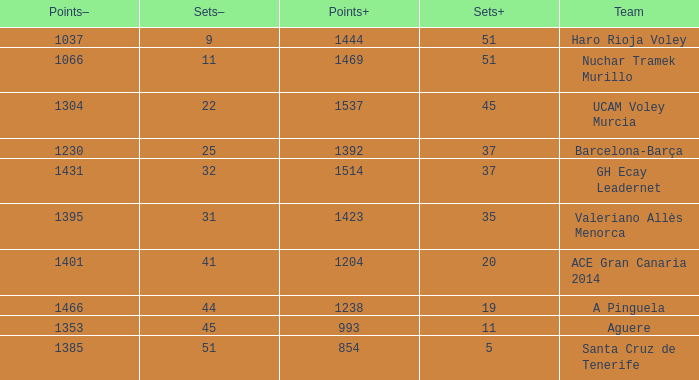What is the total number of Points- when the Sets- is larger than 51? 0.0. 